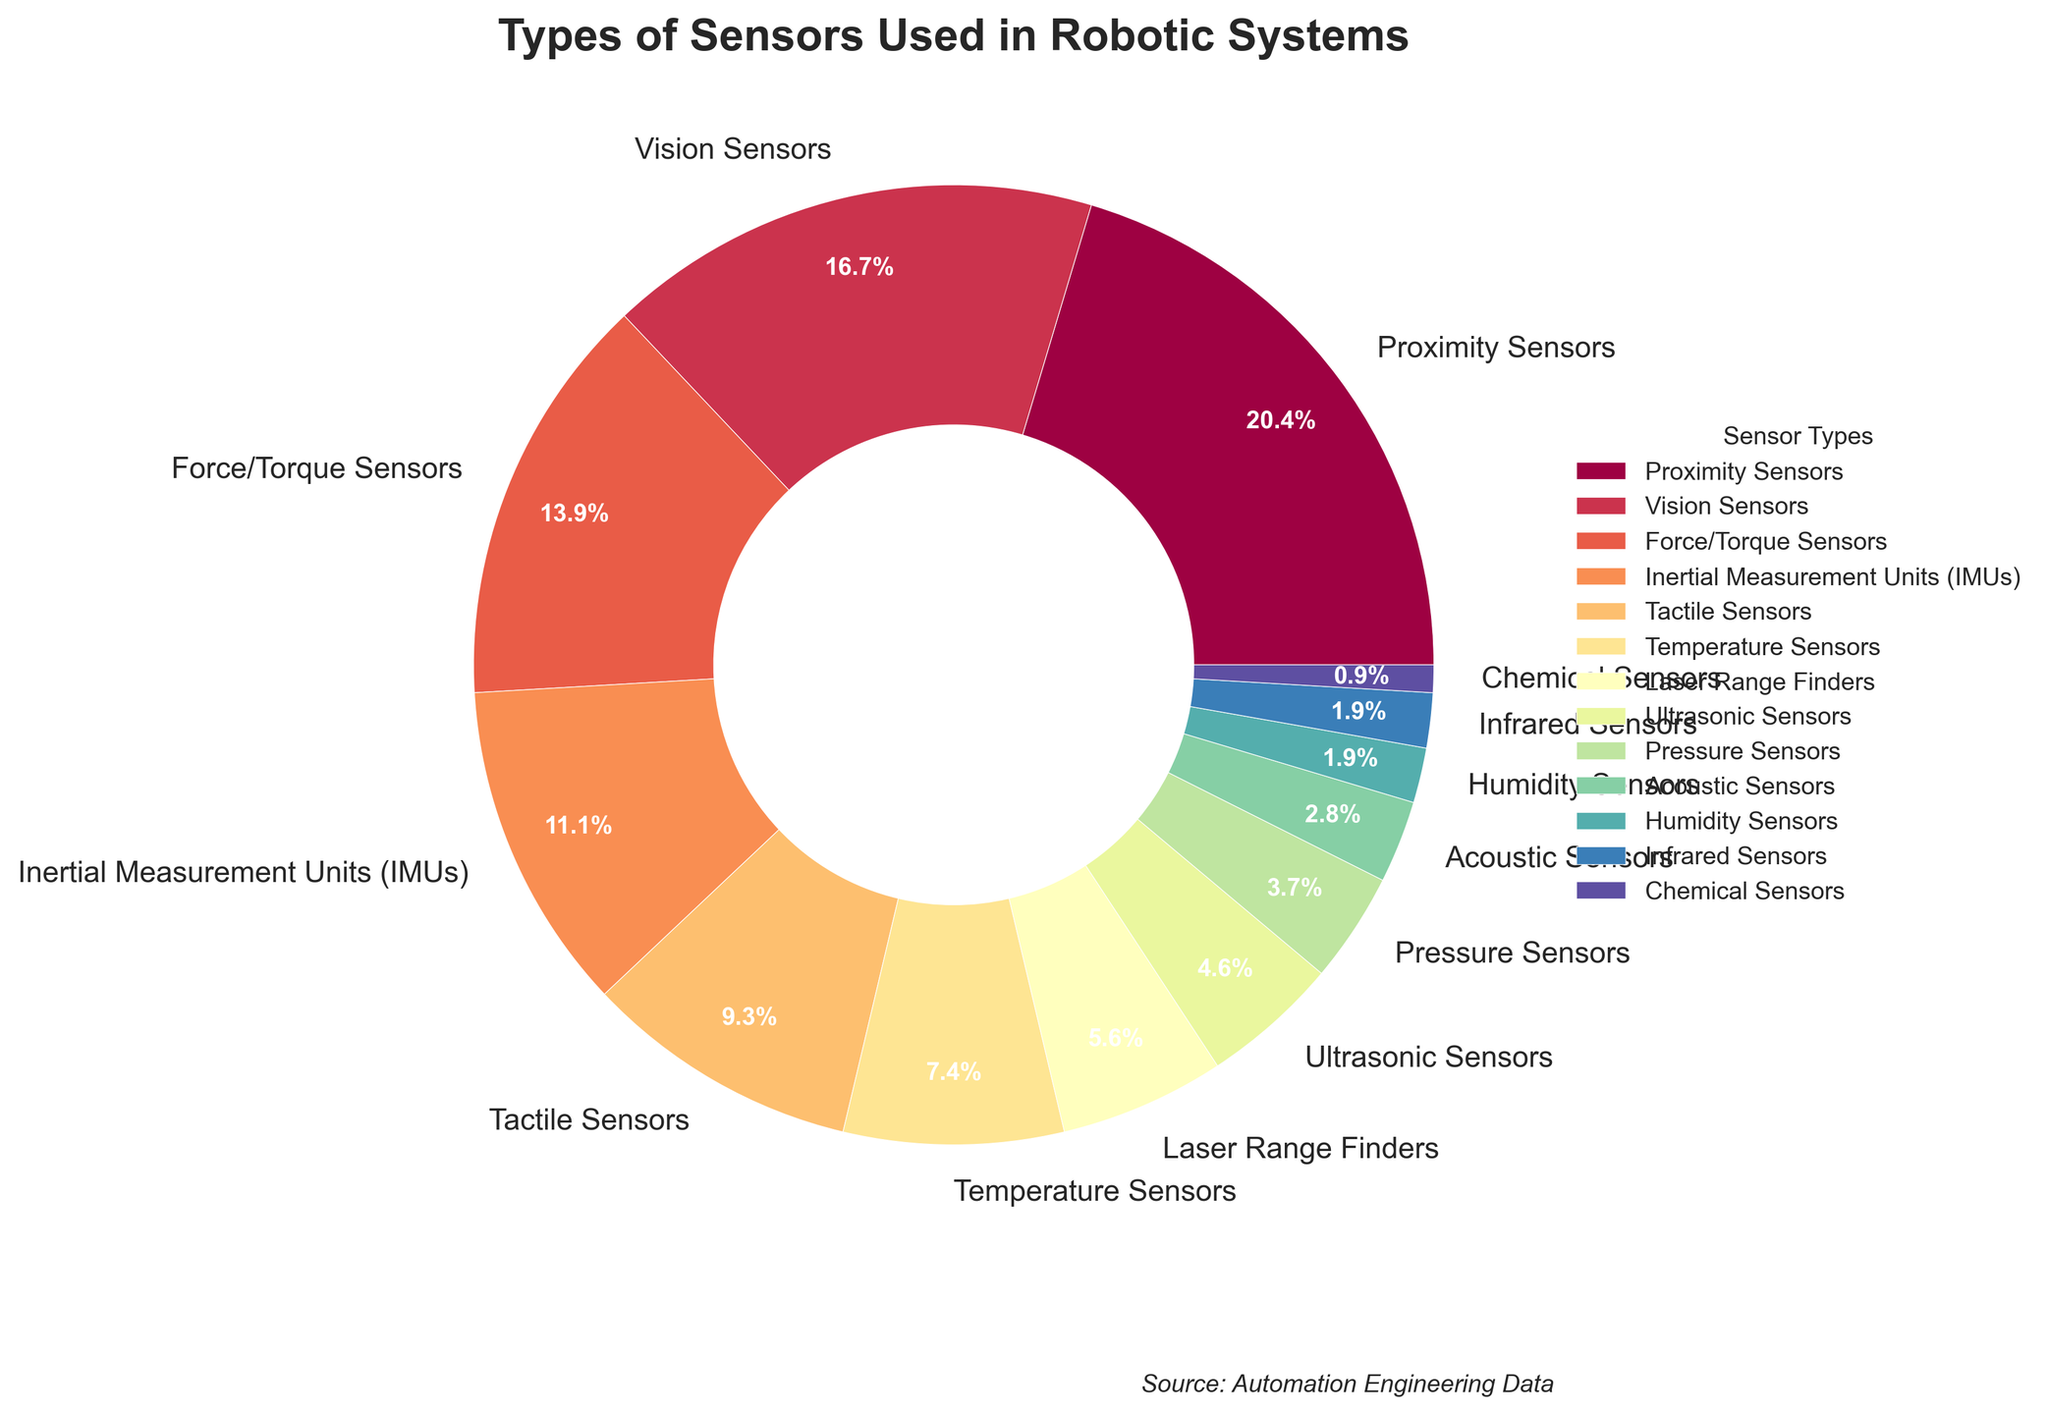Which type of sensor is used the most in robotic systems? The figure shows the percentages of different sensor types used in robotic systems. By looking at the slices, the largest one represents Proximity Sensors.
Answer: Proximity Sensors Which sensor types together make up the smallest percentage of usage? By referring to the smaller slices of the pie chart, the smallest percentages are represented by Chemical Sensors (1%) and Infrared Sensors (2%).
Answer: Chemical and Infrared Sensors What is the combined percentage of Vision Sensors and Inertial Measurement Units (IMUs)? The pie chart shows that Vision Sensors have a percentage of 18% and IMUs have 12%. Adding these together: 18% + 12% = 30%.
Answer: 30% Are Force/Torque Sensors used more commonly than Tactile Sensors? By comparing the slices visually, the Force/Torque Sensors slice (15%) is larger than the Tactile Sensors slice (10%).
Answer: Yes What is the difference in percentage usage between Temperature Sensors and Acoustic Sensors? The pie chart shows that Temperature Sensors have a percentage of 8% and Acoustic Sensors have 3%. Subtracting these: 8% - 3% = 5%.
Answer: 5% Which color represents Humidity Sensors, and what is its percentage? The legend shows that Humidity Sensors are represented by a specific color, which corresponds to a slice with a percentage of 2%.
Answer: The color used in the chart for Humidity Sensors and 2% Do Ultrasonic Sensors have a higher percentage than Laser Range Finders? By looking at the slices, Ultrasonic Sensors have 5% while Laser Range Finders have 6%.
Answer: No Which sensor type, other than Proximity Sensors, makes up more than 15% of usage? Besides Proximity Sensors, the only other type with more than 15% is Vision Sensors at 18%.
Answer: Vision Sensors What is the sum percentage for the sensors having less than 10% each? Adding the percentages of sensors under 10%: Tactile Sensors (10%) + Temperature Sensors (8%) + Laser Range Finders (6%) + Ultrasonic Sensors (5%) + Pressure Sensors (4%) + Acoustic Sensors (3%) + Humidity Sensors (2%) + Infrared Sensors (2%) + Chemical Sensors (1%) equals 41%.
Answer: 41% Which sensor type has approximately half the usage percentage of Proximity Sensors? Comparing the slices, Vision Sensors have 18%, which is close but not exact. The exact half would be 11%, and none of the types are precisely half. However, IMUs with 12% are closest.
Answer: IMUs 